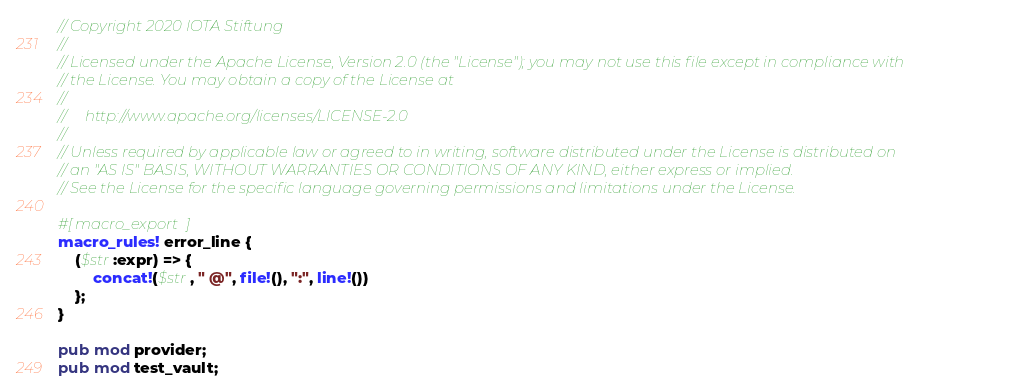Convert code to text. <code><loc_0><loc_0><loc_500><loc_500><_Rust_>// Copyright 2020 IOTA Stiftung
//
// Licensed under the Apache License, Version 2.0 (the "License"); you may not use this file except in compliance with
// the License. You may obtain a copy of the License at
//
//     http://www.apache.org/licenses/LICENSE-2.0
//
// Unless required by applicable law or agreed to in writing, software distributed under the License is distributed on
// an "AS IS" BASIS, WITHOUT WARRANTIES OR CONDITIONS OF ANY KIND, either express or implied.
// See the License for the specific language governing permissions and limitations under the License.

#[macro_export]
macro_rules! error_line {
    ($str:expr) => {
        concat!($str, " @", file!(), ":", line!())
    };
}

pub mod provider;
pub mod test_vault;
</code> 